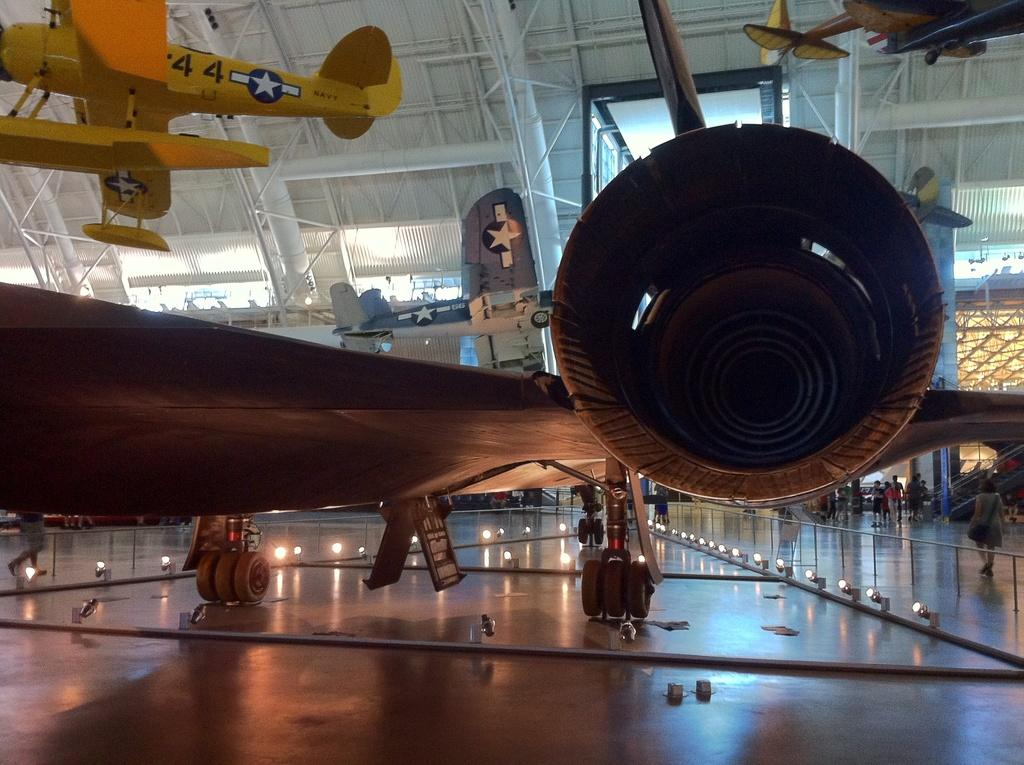What is the main subject of the image? The main subject of the image is aircrafts. What colors are the aircrafts in the image? The aircrafts are in grey and yellow colors. Where are the aircrafts located in the image? The aircrafts are inside a building. What can be seen above the aircrafts in the image? There is a roof visible in the image. What type of skin condition can be seen on the aircrafts in the image? There is no skin condition present on the aircrafts in the image, as they are inanimate objects. What type of trousers are the aircrafts wearing in the image? Aircrafts do not wear trousers, as they are not human or living beings. 